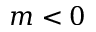Convert formula to latex. <formula><loc_0><loc_0><loc_500><loc_500>m < 0</formula> 